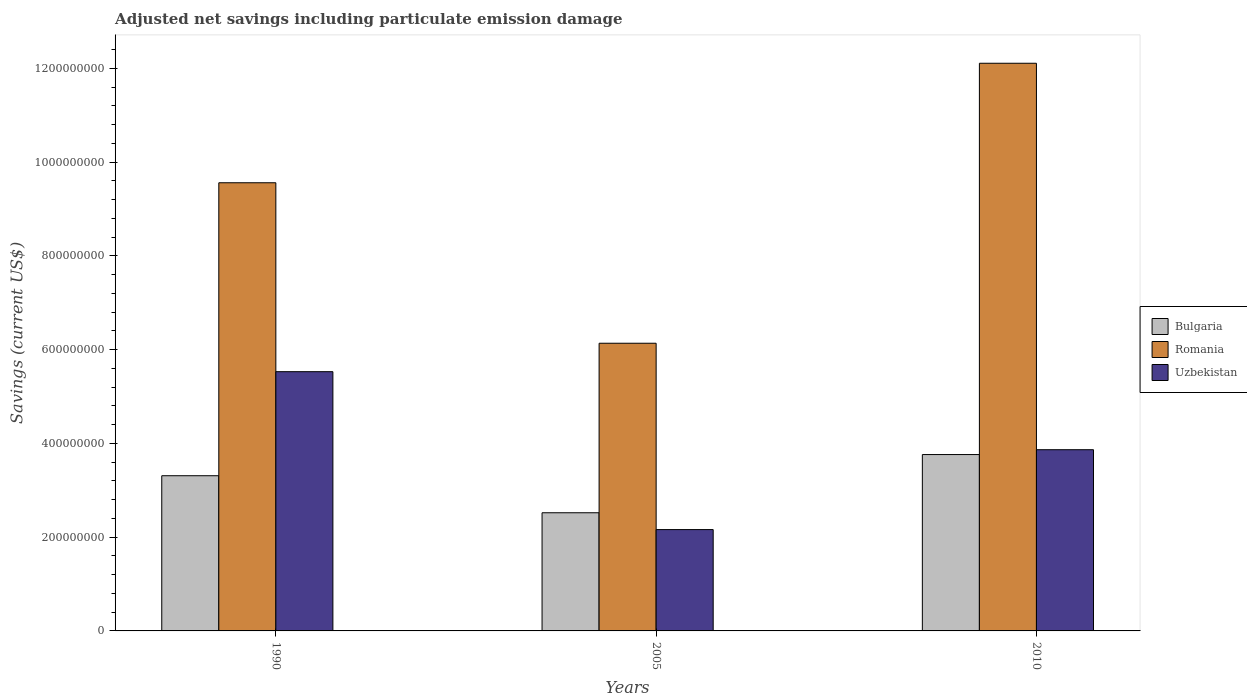How many different coloured bars are there?
Provide a short and direct response. 3. How many bars are there on the 3rd tick from the left?
Provide a short and direct response. 3. How many bars are there on the 2nd tick from the right?
Provide a succinct answer. 3. What is the net savings in Uzbekistan in 2005?
Make the answer very short. 2.16e+08. Across all years, what is the maximum net savings in Uzbekistan?
Ensure brevity in your answer.  5.53e+08. Across all years, what is the minimum net savings in Romania?
Make the answer very short. 6.14e+08. What is the total net savings in Uzbekistan in the graph?
Offer a terse response. 1.16e+09. What is the difference between the net savings in Romania in 1990 and that in 2005?
Offer a very short reply. 3.42e+08. What is the difference between the net savings in Romania in 2010 and the net savings in Bulgaria in 2005?
Your answer should be compact. 9.59e+08. What is the average net savings in Bulgaria per year?
Give a very brief answer. 3.20e+08. In the year 2010, what is the difference between the net savings in Uzbekistan and net savings in Bulgaria?
Provide a short and direct response. 1.03e+07. What is the ratio of the net savings in Bulgaria in 1990 to that in 2005?
Your answer should be very brief. 1.31. What is the difference between the highest and the second highest net savings in Uzbekistan?
Offer a terse response. 1.66e+08. What is the difference between the highest and the lowest net savings in Uzbekistan?
Ensure brevity in your answer.  3.37e+08. Is the sum of the net savings in Uzbekistan in 2005 and 2010 greater than the maximum net savings in Bulgaria across all years?
Give a very brief answer. Yes. What does the 3rd bar from the left in 2010 represents?
Provide a short and direct response. Uzbekistan. What does the 1st bar from the right in 2010 represents?
Provide a short and direct response. Uzbekistan. Is it the case that in every year, the sum of the net savings in Bulgaria and net savings in Uzbekistan is greater than the net savings in Romania?
Offer a terse response. No. How many bars are there?
Provide a succinct answer. 9. What is the difference between two consecutive major ticks on the Y-axis?
Ensure brevity in your answer.  2.00e+08. Are the values on the major ticks of Y-axis written in scientific E-notation?
Provide a short and direct response. No. Does the graph contain grids?
Your response must be concise. No. Where does the legend appear in the graph?
Your response must be concise. Center right. How many legend labels are there?
Offer a very short reply. 3. What is the title of the graph?
Ensure brevity in your answer.  Adjusted net savings including particulate emission damage. What is the label or title of the Y-axis?
Give a very brief answer. Savings (current US$). What is the Savings (current US$) in Bulgaria in 1990?
Offer a very short reply. 3.31e+08. What is the Savings (current US$) in Romania in 1990?
Give a very brief answer. 9.56e+08. What is the Savings (current US$) of Uzbekistan in 1990?
Give a very brief answer. 5.53e+08. What is the Savings (current US$) of Bulgaria in 2005?
Keep it short and to the point. 2.52e+08. What is the Savings (current US$) in Romania in 2005?
Keep it short and to the point. 6.14e+08. What is the Savings (current US$) in Uzbekistan in 2005?
Offer a terse response. 2.16e+08. What is the Savings (current US$) of Bulgaria in 2010?
Your answer should be compact. 3.76e+08. What is the Savings (current US$) of Romania in 2010?
Ensure brevity in your answer.  1.21e+09. What is the Savings (current US$) of Uzbekistan in 2010?
Your answer should be compact. 3.87e+08. Across all years, what is the maximum Savings (current US$) of Bulgaria?
Provide a succinct answer. 3.76e+08. Across all years, what is the maximum Savings (current US$) of Romania?
Provide a short and direct response. 1.21e+09. Across all years, what is the maximum Savings (current US$) of Uzbekistan?
Provide a succinct answer. 5.53e+08. Across all years, what is the minimum Savings (current US$) in Bulgaria?
Provide a short and direct response. 2.52e+08. Across all years, what is the minimum Savings (current US$) in Romania?
Your response must be concise. 6.14e+08. Across all years, what is the minimum Savings (current US$) of Uzbekistan?
Provide a succinct answer. 2.16e+08. What is the total Savings (current US$) of Bulgaria in the graph?
Keep it short and to the point. 9.59e+08. What is the total Savings (current US$) in Romania in the graph?
Make the answer very short. 2.78e+09. What is the total Savings (current US$) in Uzbekistan in the graph?
Give a very brief answer. 1.16e+09. What is the difference between the Savings (current US$) of Bulgaria in 1990 and that in 2005?
Your response must be concise. 7.90e+07. What is the difference between the Savings (current US$) in Romania in 1990 and that in 2005?
Your answer should be compact. 3.42e+08. What is the difference between the Savings (current US$) of Uzbekistan in 1990 and that in 2005?
Provide a succinct answer. 3.37e+08. What is the difference between the Savings (current US$) in Bulgaria in 1990 and that in 2010?
Your answer should be very brief. -4.52e+07. What is the difference between the Savings (current US$) of Romania in 1990 and that in 2010?
Provide a succinct answer. -2.55e+08. What is the difference between the Savings (current US$) of Uzbekistan in 1990 and that in 2010?
Offer a terse response. 1.66e+08. What is the difference between the Savings (current US$) in Bulgaria in 2005 and that in 2010?
Ensure brevity in your answer.  -1.24e+08. What is the difference between the Savings (current US$) of Romania in 2005 and that in 2010?
Ensure brevity in your answer.  -5.97e+08. What is the difference between the Savings (current US$) of Uzbekistan in 2005 and that in 2010?
Provide a succinct answer. -1.70e+08. What is the difference between the Savings (current US$) of Bulgaria in 1990 and the Savings (current US$) of Romania in 2005?
Your response must be concise. -2.83e+08. What is the difference between the Savings (current US$) of Bulgaria in 1990 and the Savings (current US$) of Uzbekistan in 2005?
Your answer should be compact. 1.15e+08. What is the difference between the Savings (current US$) of Romania in 1990 and the Savings (current US$) of Uzbekistan in 2005?
Give a very brief answer. 7.40e+08. What is the difference between the Savings (current US$) in Bulgaria in 1990 and the Savings (current US$) in Romania in 2010?
Offer a very short reply. -8.80e+08. What is the difference between the Savings (current US$) of Bulgaria in 1990 and the Savings (current US$) of Uzbekistan in 2010?
Provide a succinct answer. -5.55e+07. What is the difference between the Savings (current US$) of Romania in 1990 and the Savings (current US$) of Uzbekistan in 2010?
Make the answer very short. 5.70e+08. What is the difference between the Savings (current US$) in Bulgaria in 2005 and the Savings (current US$) in Romania in 2010?
Ensure brevity in your answer.  -9.59e+08. What is the difference between the Savings (current US$) in Bulgaria in 2005 and the Savings (current US$) in Uzbekistan in 2010?
Provide a short and direct response. -1.34e+08. What is the difference between the Savings (current US$) of Romania in 2005 and the Savings (current US$) of Uzbekistan in 2010?
Your response must be concise. 2.27e+08. What is the average Savings (current US$) in Bulgaria per year?
Give a very brief answer. 3.20e+08. What is the average Savings (current US$) in Romania per year?
Offer a terse response. 9.27e+08. What is the average Savings (current US$) of Uzbekistan per year?
Make the answer very short. 3.85e+08. In the year 1990, what is the difference between the Savings (current US$) in Bulgaria and Savings (current US$) in Romania?
Your answer should be very brief. -6.25e+08. In the year 1990, what is the difference between the Savings (current US$) of Bulgaria and Savings (current US$) of Uzbekistan?
Your answer should be compact. -2.22e+08. In the year 1990, what is the difference between the Savings (current US$) in Romania and Savings (current US$) in Uzbekistan?
Your response must be concise. 4.03e+08. In the year 2005, what is the difference between the Savings (current US$) in Bulgaria and Savings (current US$) in Romania?
Offer a terse response. -3.62e+08. In the year 2005, what is the difference between the Savings (current US$) in Bulgaria and Savings (current US$) in Uzbekistan?
Make the answer very short. 3.59e+07. In the year 2005, what is the difference between the Savings (current US$) in Romania and Savings (current US$) in Uzbekistan?
Provide a succinct answer. 3.98e+08. In the year 2010, what is the difference between the Savings (current US$) of Bulgaria and Savings (current US$) of Romania?
Keep it short and to the point. -8.35e+08. In the year 2010, what is the difference between the Savings (current US$) of Bulgaria and Savings (current US$) of Uzbekistan?
Ensure brevity in your answer.  -1.03e+07. In the year 2010, what is the difference between the Savings (current US$) of Romania and Savings (current US$) of Uzbekistan?
Your answer should be compact. 8.24e+08. What is the ratio of the Savings (current US$) in Bulgaria in 1990 to that in 2005?
Your response must be concise. 1.31. What is the ratio of the Savings (current US$) in Romania in 1990 to that in 2005?
Ensure brevity in your answer.  1.56. What is the ratio of the Savings (current US$) in Uzbekistan in 1990 to that in 2005?
Your response must be concise. 2.56. What is the ratio of the Savings (current US$) of Romania in 1990 to that in 2010?
Make the answer very short. 0.79. What is the ratio of the Savings (current US$) in Uzbekistan in 1990 to that in 2010?
Give a very brief answer. 1.43. What is the ratio of the Savings (current US$) of Bulgaria in 2005 to that in 2010?
Provide a succinct answer. 0.67. What is the ratio of the Savings (current US$) of Romania in 2005 to that in 2010?
Provide a succinct answer. 0.51. What is the ratio of the Savings (current US$) in Uzbekistan in 2005 to that in 2010?
Your answer should be very brief. 0.56. What is the difference between the highest and the second highest Savings (current US$) of Bulgaria?
Provide a succinct answer. 4.52e+07. What is the difference between the highest and the second highest Savings (current US$) of Romania?
Give a very brief answer. 2.55e+08. What is the difference between the highest and the second highest Savings (current US$) of Uzbekistan?
Provide a succinct answer. 1.66e+08. What is the difference between the highest and the lowest Savings (current US$) in Bulgaria?
Offer a terse response. 1.24e+08. What is the difference between the highest and the lowest Savings (current US$) of Romania?
Offer a very short reply. 5.97e+08. What is the difference between the highest and the lowest Savings (current US$) in Uzbekistan?
Ensure brevity in your answer.  3.37e+08. 